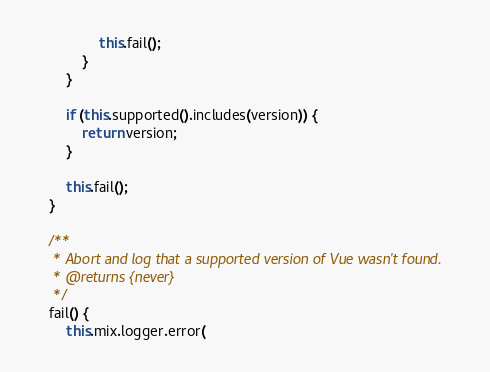<code> <loc_0><loc_0><loc_500><loc_500><_JavaScript_>                this.fail();
            }
        }

        if (this.supported().includes(version)) {
            return version;
        }

        this.fail();
    }

    /**
     * Abort and log that a supported version of Vue wasn't found.
     * @returns {never}
     */
    fail() {
        this.mix.logger.error(</code> 